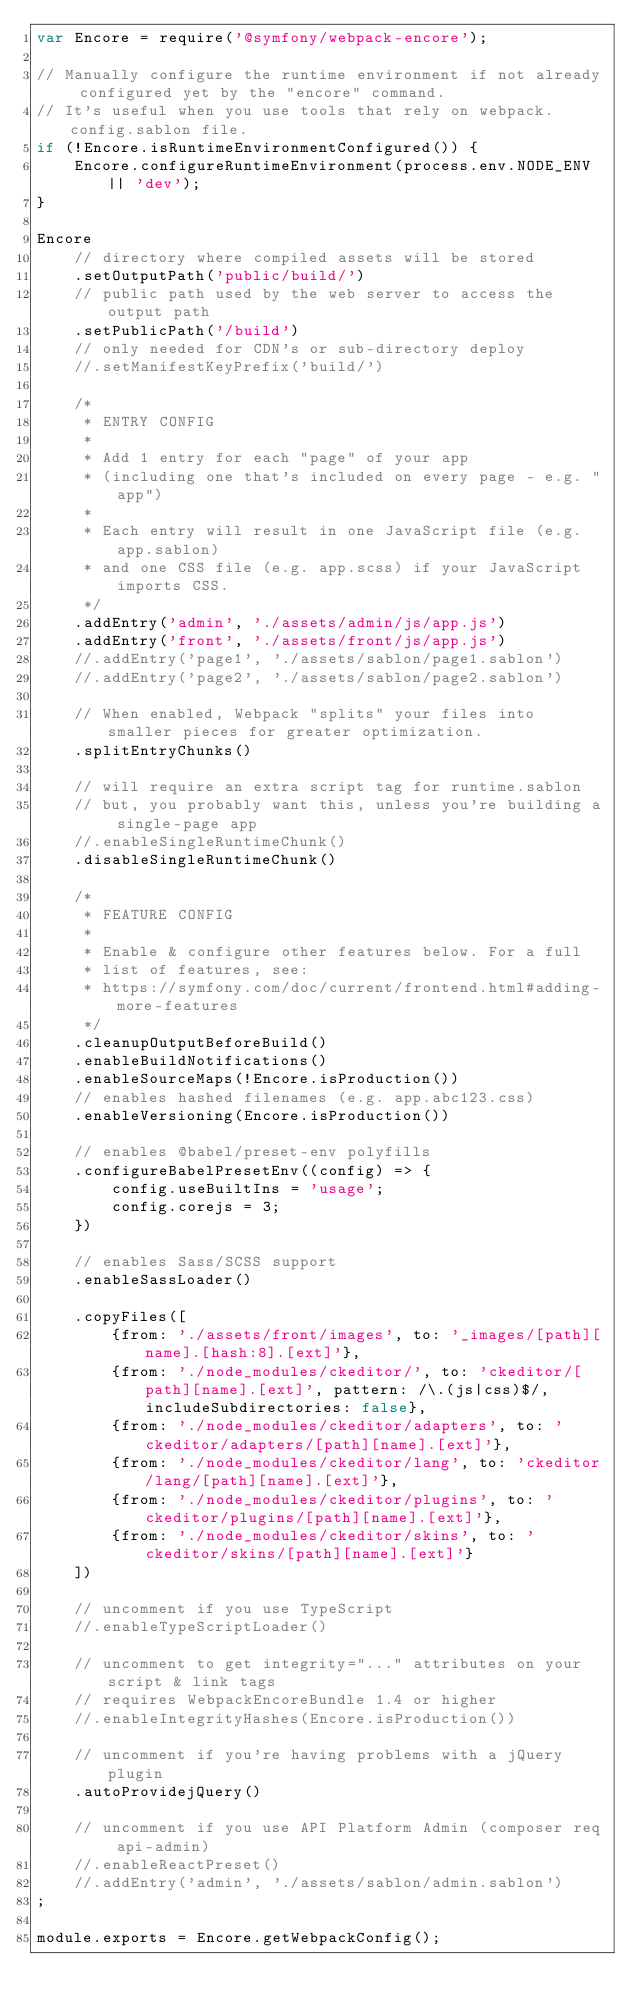<code> <loc_0><loc_0><loc_500><loc_500><_JavaScript_>var Encore = require('@symfony/webpack-encore');

// Manually configure the runtime environment if not already configured yet by the "encore" command.
// It's useful when you use tools that rely on webpack.config.sablon file.
if (!Encore.isRuntimeEnvironmentConfigured()) {
    Encore.configureRuntimeEnvironment(process.env.NODE_ENV || 'dev');
}

Encore
    // directory where compiled assets will be stored
    .setOutputPath('public/build/')
    // public path used by the web server to access the output path
    .setPublicPath('/build')
    // only needed for CDN's or sub-directory deploy
    //.setManifestKeyPrefix('build/')

    /*
     * ENTRY CONFIG
     *
     * Add 1 entry for each "page" of your app
     * (including one that's included on every page - e.g. "app")
     *
     * Each entry will result in one JavaScript file (e.g. app.sablon)
     * and one CSS file (e.g. app.scss) if your JavaScript imports CSS.
     */
    .addEntry('admin', './assets/admin/js/app.js')
    .addEntry('front', './assets/front/js/app.js')
    //.addEntry('page1', './assets/sablon/page1.sablon')
    //.addEntry('page2', './assets/sablon/page2.sablon')

    // When enabled, Webpack "splits" your files into smaller pieces for greater optimization.
    .splitEntryChunks()

    // will require an extra script tag for runtime.sablon
    // but, you probably want this, unless you're building a single-page app
    //.enableSingleRuntimeChunk()
    .disableSingleRuntimeChunk()

    /*
     * FEATURE CONFIG
     *
     * Enable & configure other features below. For a full
     * list of features, see:
     * https://symfony.com/doc/current/frontend.html#adding-more-features
     */
    .cleanupOutputBeforeBuild()
    .enableBuildNotifications()
    .enableSourceMaps(!Encore.isProduction())
    // enables hashed filenames (e.g. app.abc123.css)
    .enableVersioning(Encore.isProduction())

    // enables @babel/preset-env polyfills
    .configureBabelPresetEnv((config) => {
        config.useBuiltIns = 'usage';
        config.corejs = 3;
    })

    // enables Sass/SCSS support
    .enableSassLoader()

    .copyFiles([
        {from: './assets/front/images', to: '_images/[path][name].[hash:8].[ext]'},
        {from: './node_modules/ckeditor/', to: 'ckeditor/[path][name].[ext]', pattern: /\.(js|css)$/, includeSubdirectories: false},
        {from: './node_modules/ckeditor/adapters', to: 'ckeditor/adapters/[path][name].[ext]'},
        {from: './node_modules/ckeditor/lang', to: 'ckeditor/lang/[path][name].[ext]'},
        {from: './node_modules/ckeditor/plugins', to: 'ckeditor/plugins/[path][name].[ext]'},
        {from: './node_modules/ckeditor/skins', to: 'ckeditor/skins/[path][name].[ext]'}
    ])

    // uncomment if you use TypeScript
    //.enableTypeScriptLoader()

    // uncomment to get integrity="..." attributes on your script & link tags
    // requires WebpackEncoreBundle 1.4 or higher
    //.enableIntegrityHashes(Encore.isProduction())

    // uncomment if you're having problems with a jQuery plugin
    .autoProvidejQuery()

    // uncomment if you use API Platform Admin (composer req api-admin)
    //.enableReactPreset()
    //.addEntry('admin', './assets/sablon/admin.sablon')
;

module.exports = Encore.getWebpackConfig();
</code> 